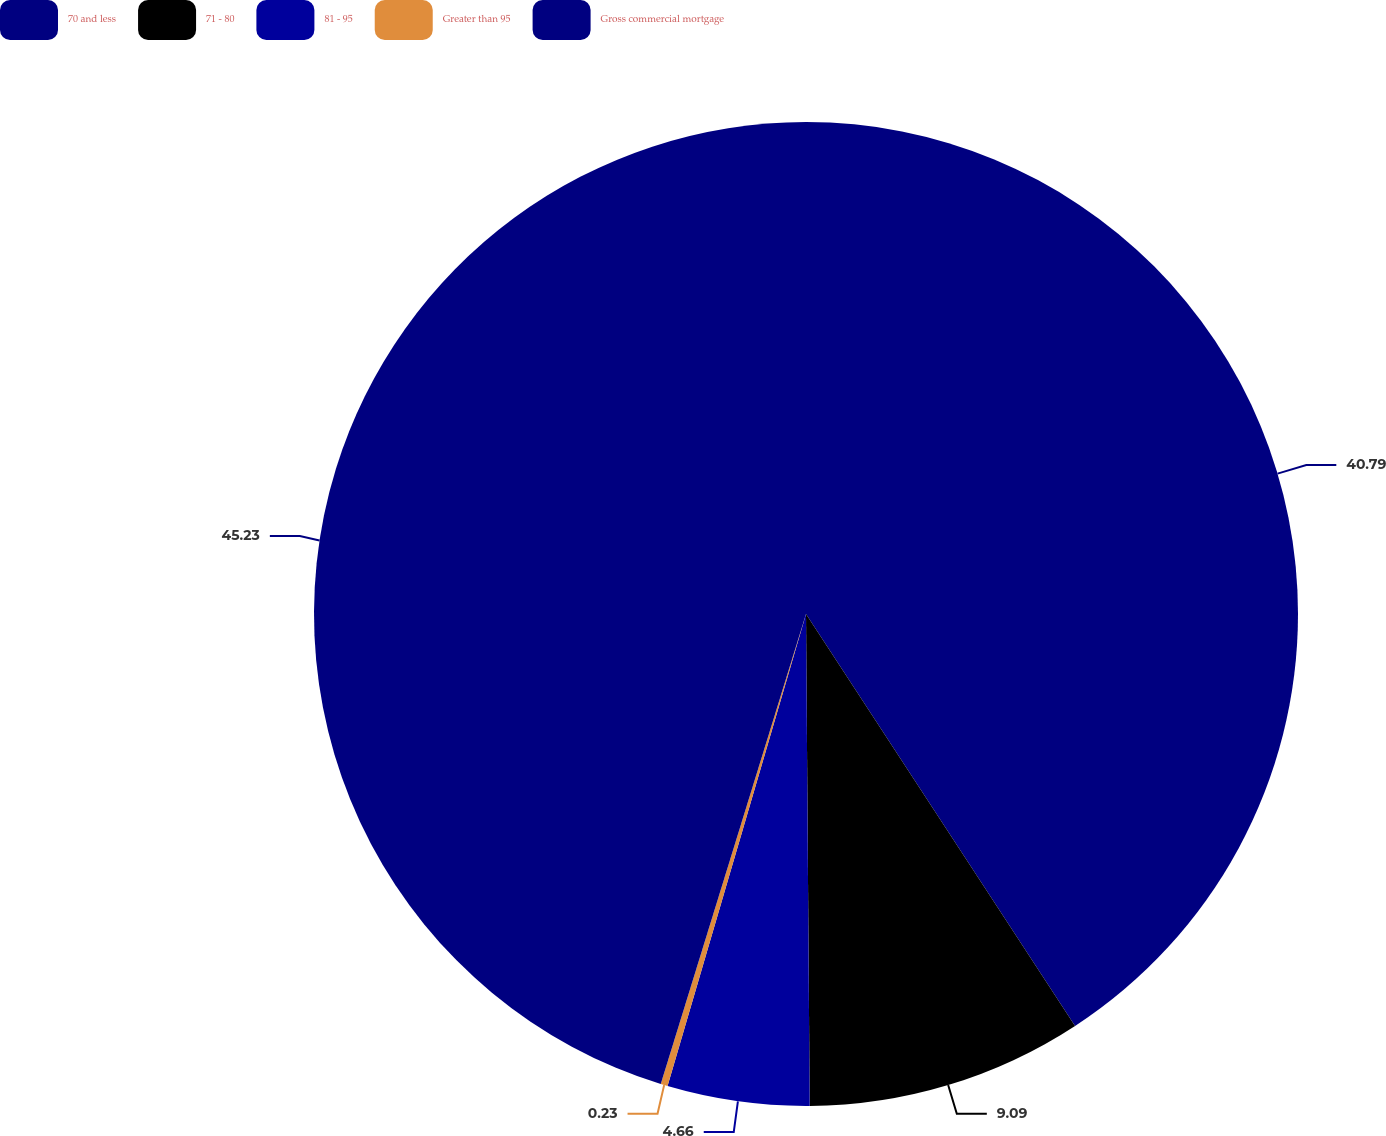Convert chart to OTSL. <chart><loc_0><loc_0><loc_500><loc_500><pie_chart><fcel>70 and less<fcel>71 - 80<fcel>81 - 95<fcel>Greater than 95<fcel>Gross commercial mortgage<nl><fcel>40.79%<fcel>9.09%<fcel>4.66%<fcel>0.23%<fcel>45.23%<nl></chart> 